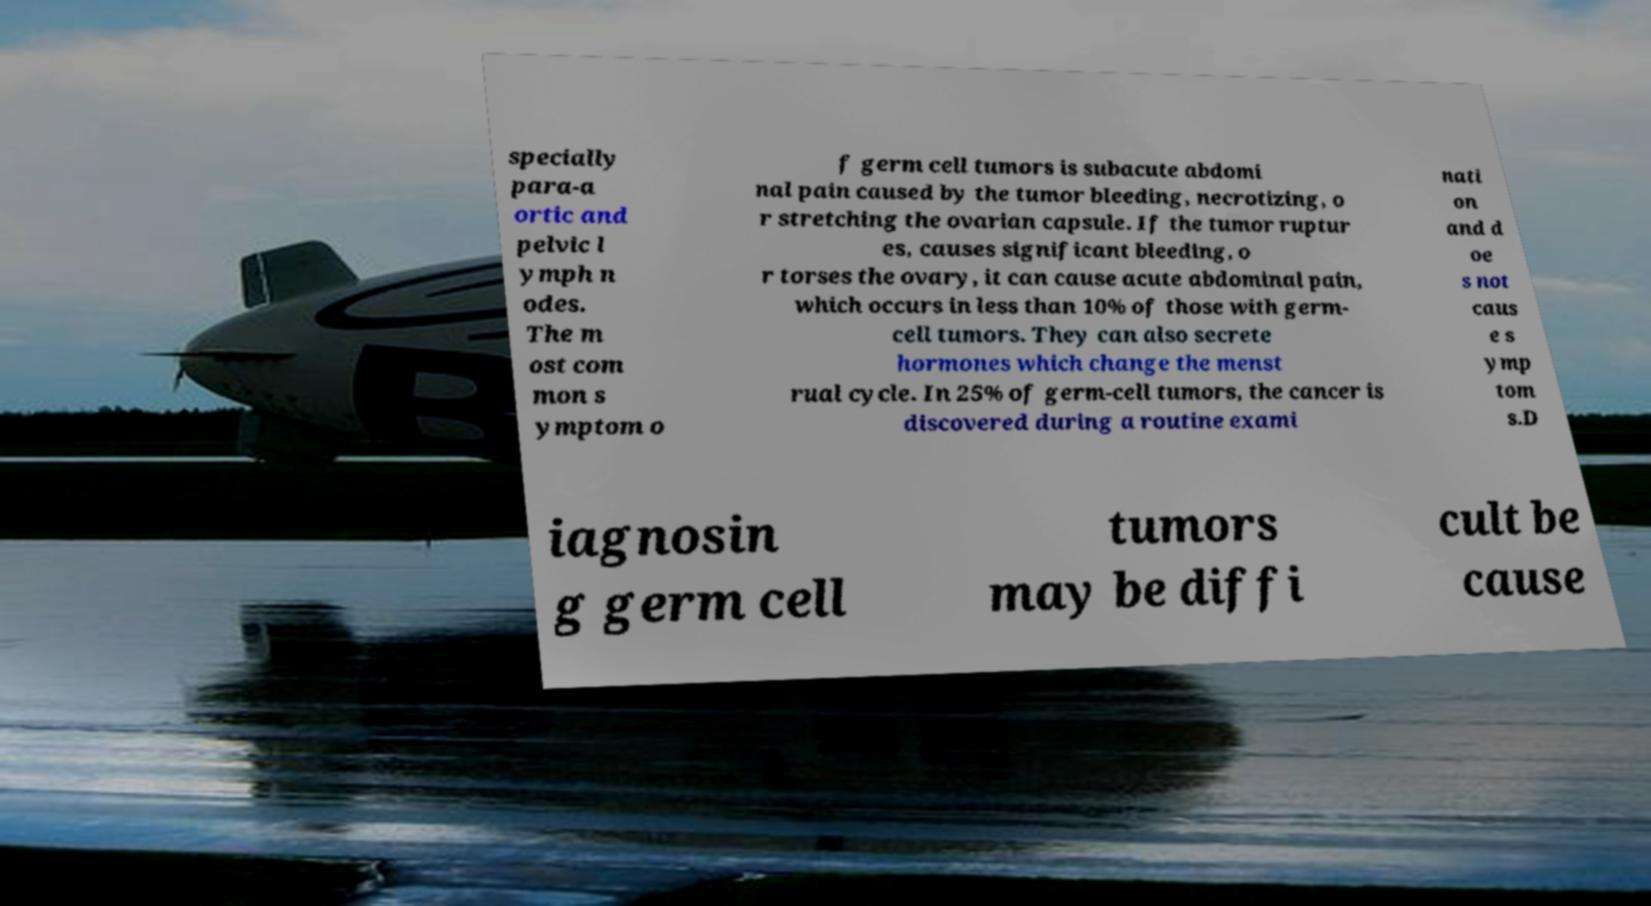There's text embedded in this image that I need extracted. Can you transcribe it verbatim? specially para-a ortic and pelvic l ymph n odes. The m ost com mon s ymptom o f germ cell tumors is subacute abdomi nal pain caused by the tumor bleeding, necrotizing, o r stretching the ovarian capsule. If the tumor ruptur es, causes significant bleeding, o r torses the ovary, it can cause acute abdominal pain, which occurs in less than 10% of those with germ- cell tumors. They can also secrete hormones which change the menst rual cycle. In 25% of germ-cell tumors, the cancer is discovered during a routine exami nati on and d oe s not caus e s ymp tom s.D iagnosin g germ cell tumors may be diffi cult be cause 